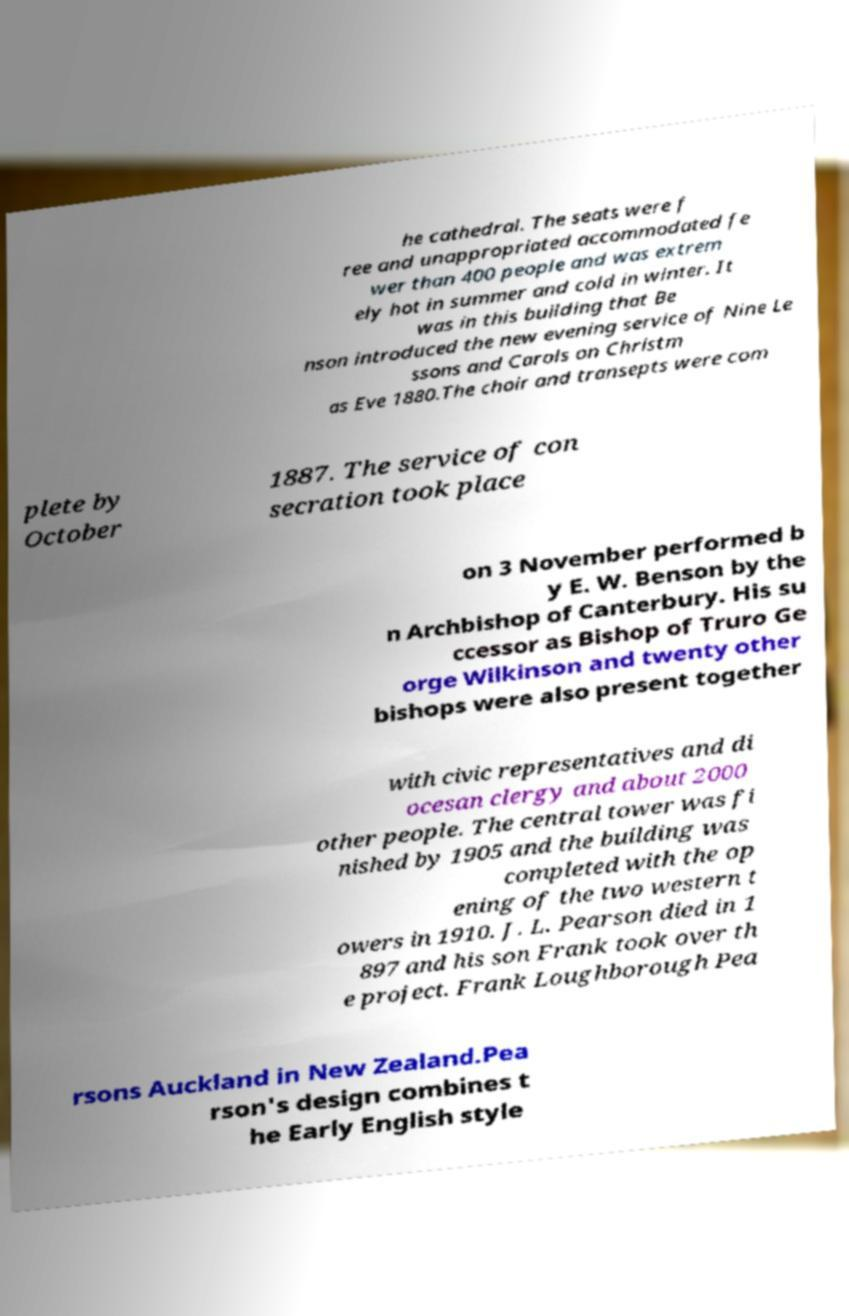Please read and relay the text visible in this image. What does it say? he cathedral. The seats were f ree and unappropriated accommodated fe wer than 400 people and was extrem ely hot in summer and cold in winter. It was in this building that Be nson introduced the new evening service of Nine Le ssons and Carols on Christm as Eve 1880.The choir and transepts were com plete by October 1887. The service of con secration took place on 3 November performed b y E. W. Benson by the n Archbishop of Canterbury. His su ccessor as Bishop of Truro Ge orge Wilkinson and twenty other bishops were also present together with civic representatives and di ocesan clergy and about 2000 other people. The central tower was fi nished by 1905 and the building was completed with the op ening of the two western t owers in 1910. J. L. Pearson died in 1 897 and his son Frank took over th e project. Frank Loughborough Pea rsons Auckland in New Zealand.Pea rson's design combines t he Early English style 